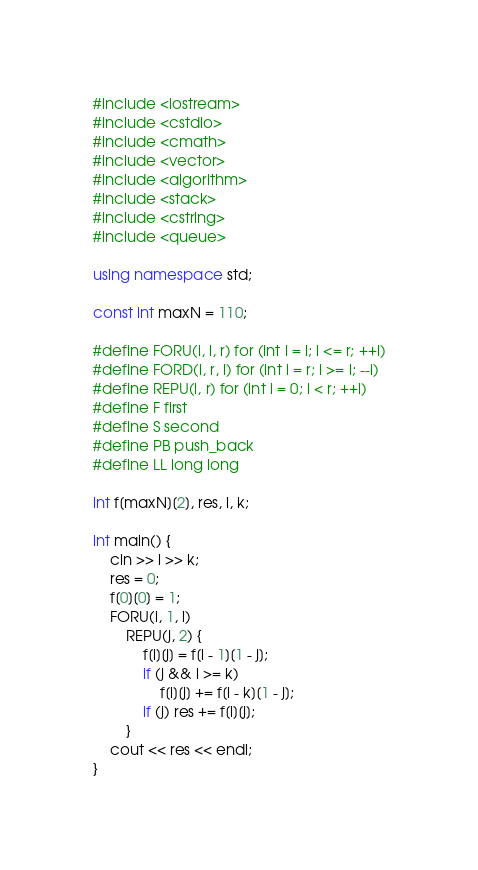<code> <loc_0><loc_0><loc_500><loc_500><_C++_>#include <iostream>
#include <cstdio>
#include <cmath>
#include <vector>
#include <algorithm>
#include <stack>
#include <cstring>
#include <queue>

using namespace std;

const int maxN = 110;

#define FORU(i, l, r) for (int i = l; i <= r; ++i)
#define FORD(i, r, l) for (int i = r; i >= l; --i)
#define REPU(i, r) for (int i = 0; i < r; ++i)
#define F first
#define S second
#define PB push_back
#define LL long long

int f[maxN][2], res, l, k;

int main() {
    cin >> l >> k;
    res = 0;
    f[0][0] = 1;
    FORU(i, 1, l)
        REPU(j, 2) {
            f[i][j] = f[i - 1][1 - j];
            if (j && i >= k)
                f[i][j] += f[i - k][1 - j];
            if (j) res += f[i][j];
        }
    cout << res << endl;
}

</code> 